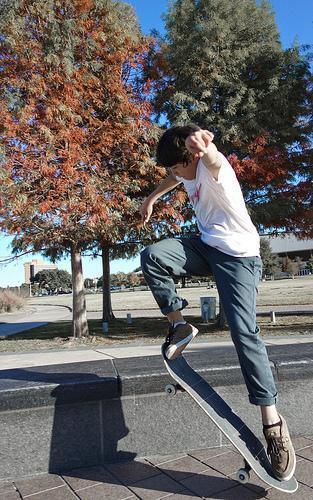How many kids skateboarding?
Give a very brief answer. 1. 